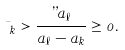<formula> <loc_0><loc_0><loc_500><loc_500>\mu _ { k } > \frac { \varepsilon a _ { \ell } } { a _ { \ell } - a _ { k } } \geq 0 .</formula> 